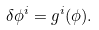<formula> <loc_0><loc_0><loc_500><loc_500>\delta \phi ^ { i } = g ^ { i } ( \phi ) .</formula> 